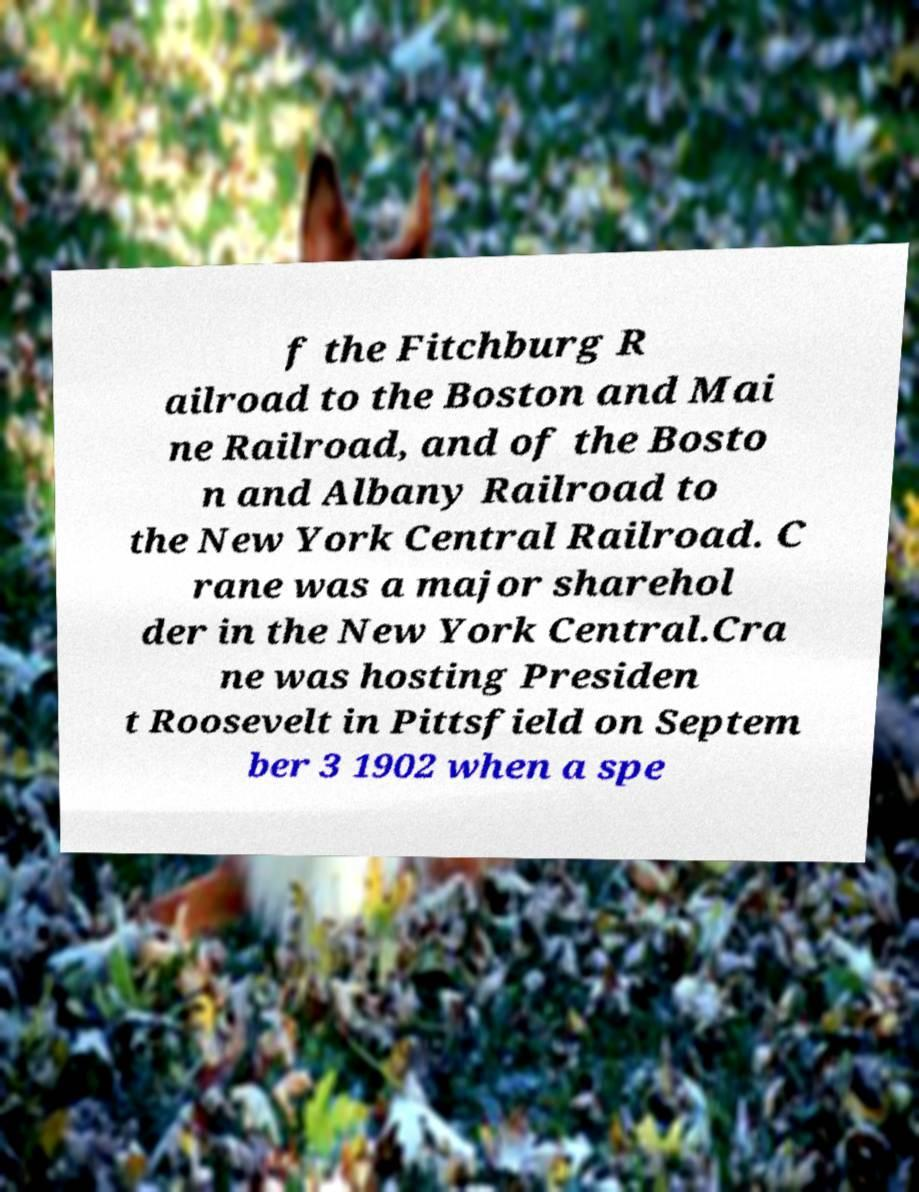For documentation purposes, I need the text within this image transcribed. Could you provide that? f the Fitchburg R ailroad to the Boston and Mai ne Railroad, and of the Bosto n and Albany Railroad to the New York Central Railroad. C rane was a major sharehol der in the New York Central.Cra ne was hosting Presiden t Roosevelt in Pittsfield on Septem ber 3 1902 when a spe 